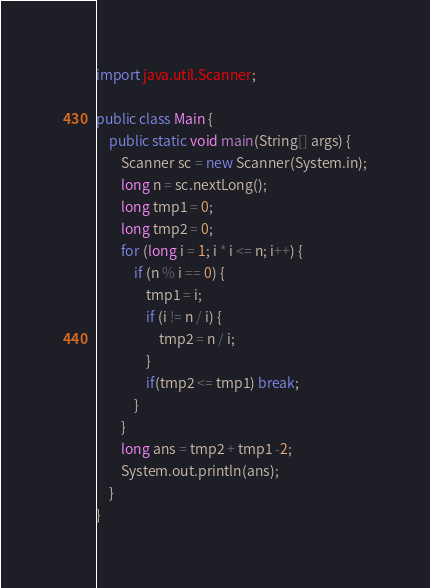<code> <loc_0><loc_0><loc_500><loc_500><_Java_>import java.util.Scanner;

public class Main {
    public static void main(String[] args) {
        Scanner sc = new Scanner(System.in);
        long n = sc.nextLong();
        long tmp1 = 0;
        long tmp2 = 0;
        for (long i = 1; i * i <= n; i++) {
            if (n % i == 0) {
                tmp1 = i;
                if (i != n / i) {
                    tmp2 = n / i;
                }
                if(tmp2 <= tmp1) break;
            }
        }
        long ans = tmp2 + tmp1 -2;
        System.out.println(ans);
    }
}</code> 